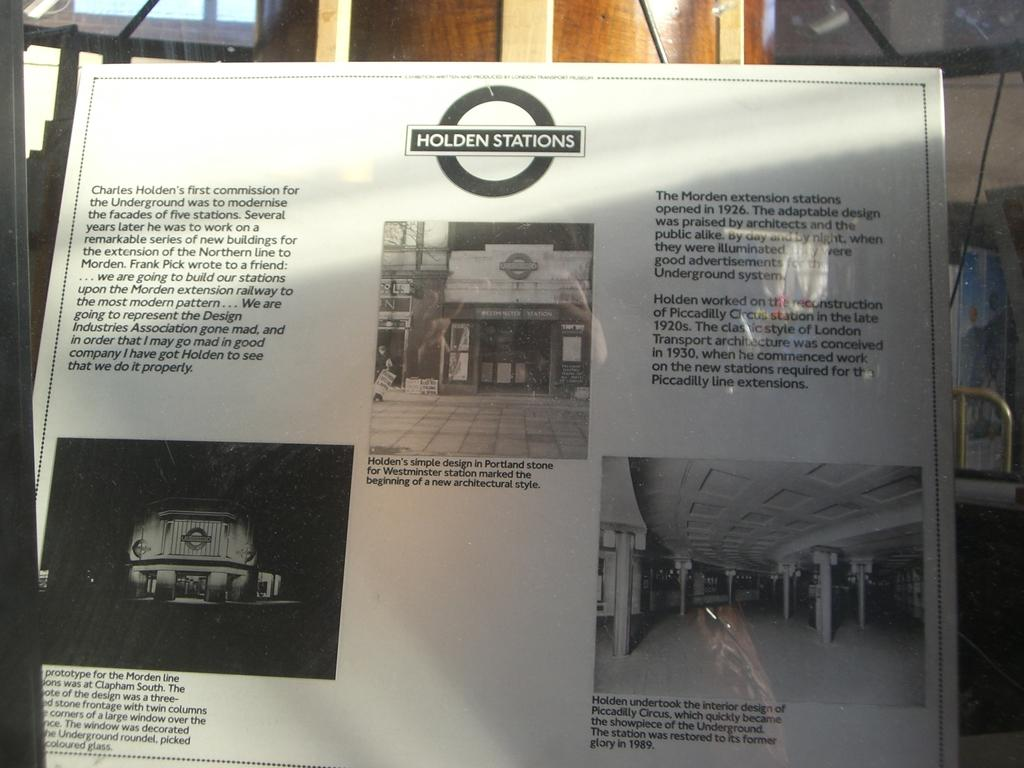<image>
Summarize the visual content of the image. A poster has the words Holden Stations at the top. 